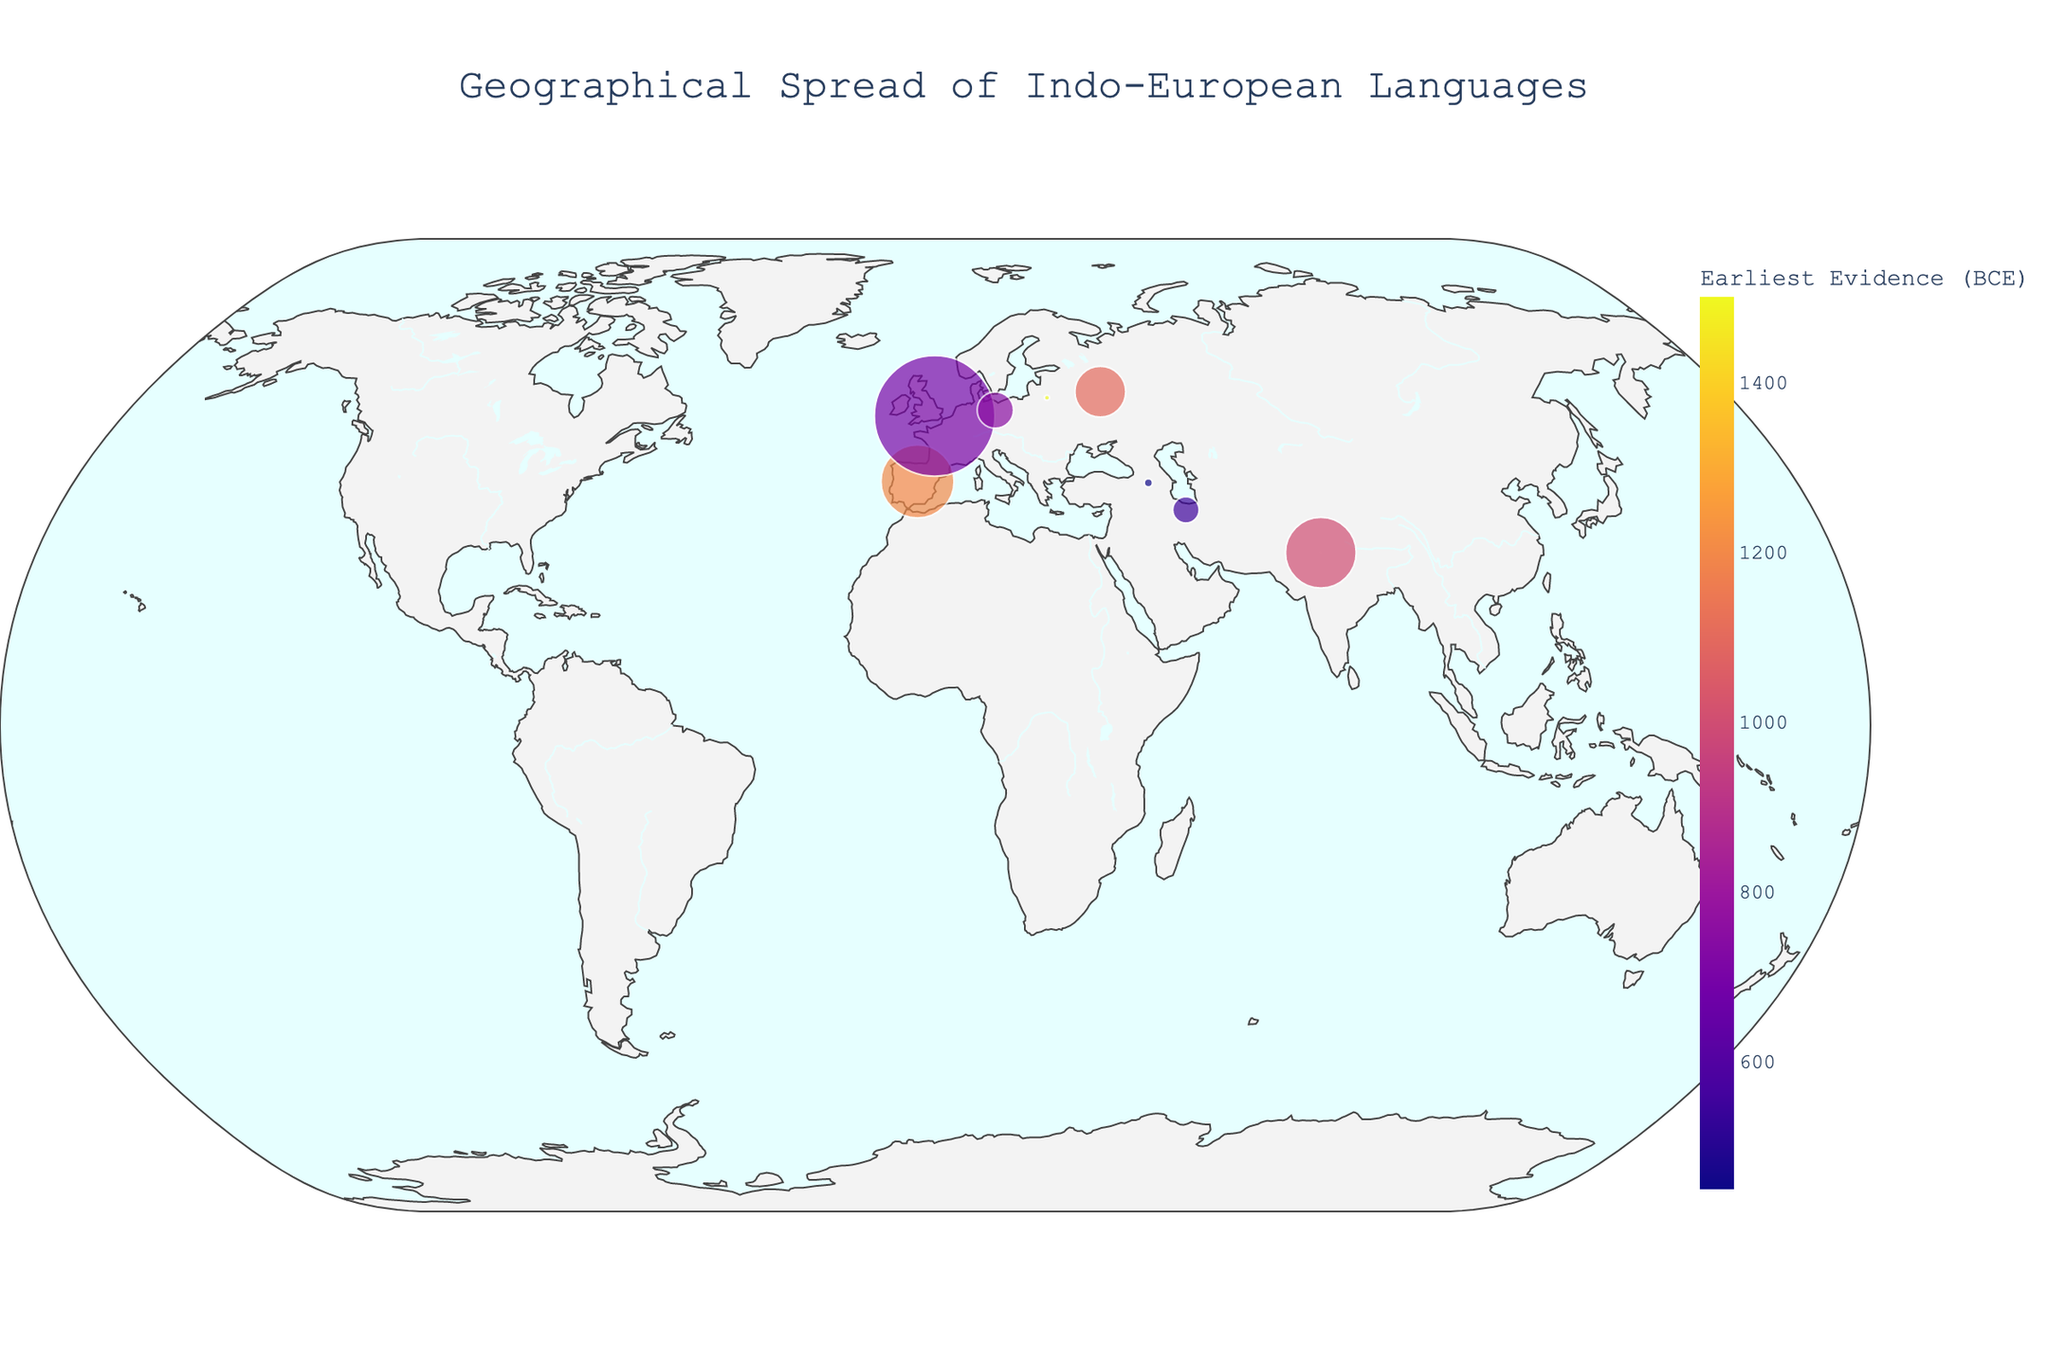what is the size of the largest circle on the plot? The size of the circles represents the number of speakers in millions. To find the largest circle, look for the data point with the highest number of speakers. English has the highest number of speakers at 1452 million.
Answer: 1452 How is the earliest evidence of the Indo-European languages represented in the plot? The earliest evidence of the Indo-European languages is represented by the color of the circles. Different colors correspond to different historical periods (BCE) when these languages have the earliest evidence.
Answer: Color of the circles Which language with more than 500 million speakers has the earliest evidence? To answer this, look for languages with circles of large size and compare their historical period based on the color. Spanish has 534 million speakers and an earliest evidence of 1200 BCE.
Answer: Spanish How many languages are shown in the plot with their earliest evidence before 1000 BCE? To determine this, count the languages with colors representing an earliest evidence BCE year before 1000. Sanskrit, Ancient Greek, Proto-Celtic, Proto-Germanic, and Proto-Slavic meet this criterion.
Answer: 5 Which language's circle is located furthest north? Look at the y-coordinate (latitude) of each circle on the map. The language circle furthest north is Old Norse, located at a latitude of 59.9139.
Answer: Old Norse Which modern-day language with the highest number of speakers originated later than 1000 BCE? Focus on circles representing modern languages and compare their earliest evidence based on color. Among the modern languages, English originated around 700 and has 1452 million speakers.
Answer: English Which language is geographically closest to Sanskrit based on their latitude and longitude coordinates? Observe the plot to determine proximity or compare the geolocation coordinates. Hindi shares the same coordinates as Sanskrit at (28.6139, 77.2090).
Answer: Hindi How many languages are shown originating from regions within the latitude range of 50-55 degrees? Count the circles within the latitude range specified. There are three: Russian, Proto-Slavic, and Lithuanian.
Answer: 3 What is the approximate historical range (in years) covered by the earliest evidence of the displayed languages? To determine the range, find the difference between the earliest and latest evidence years in BCE. The earliest evidence is Sanskrit at 1500 BCE, and the latest is Spanish at 1200 BCE. The range is 1500 - 1200 = 300 years.
Answer: 300 Which languages share nearly identical geographic coordinates but differ significantly in the number of speakers? Look for overlapping or very close circles that vary in size. Sanskrit and Hindi share nearly identical coordinates (28.6139, 77.2090) but have vastly different numbers of speakers, with Hindi having around 500 million speakers and Sanskrit around 0.01 million.
Answer: Sanskrit and Hindi 